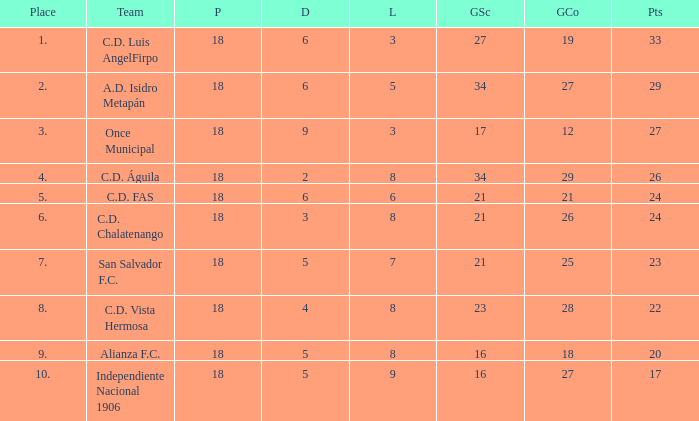For Once Municipal, what were the goals scored that had less than 27 points and greater than place 1? None. 